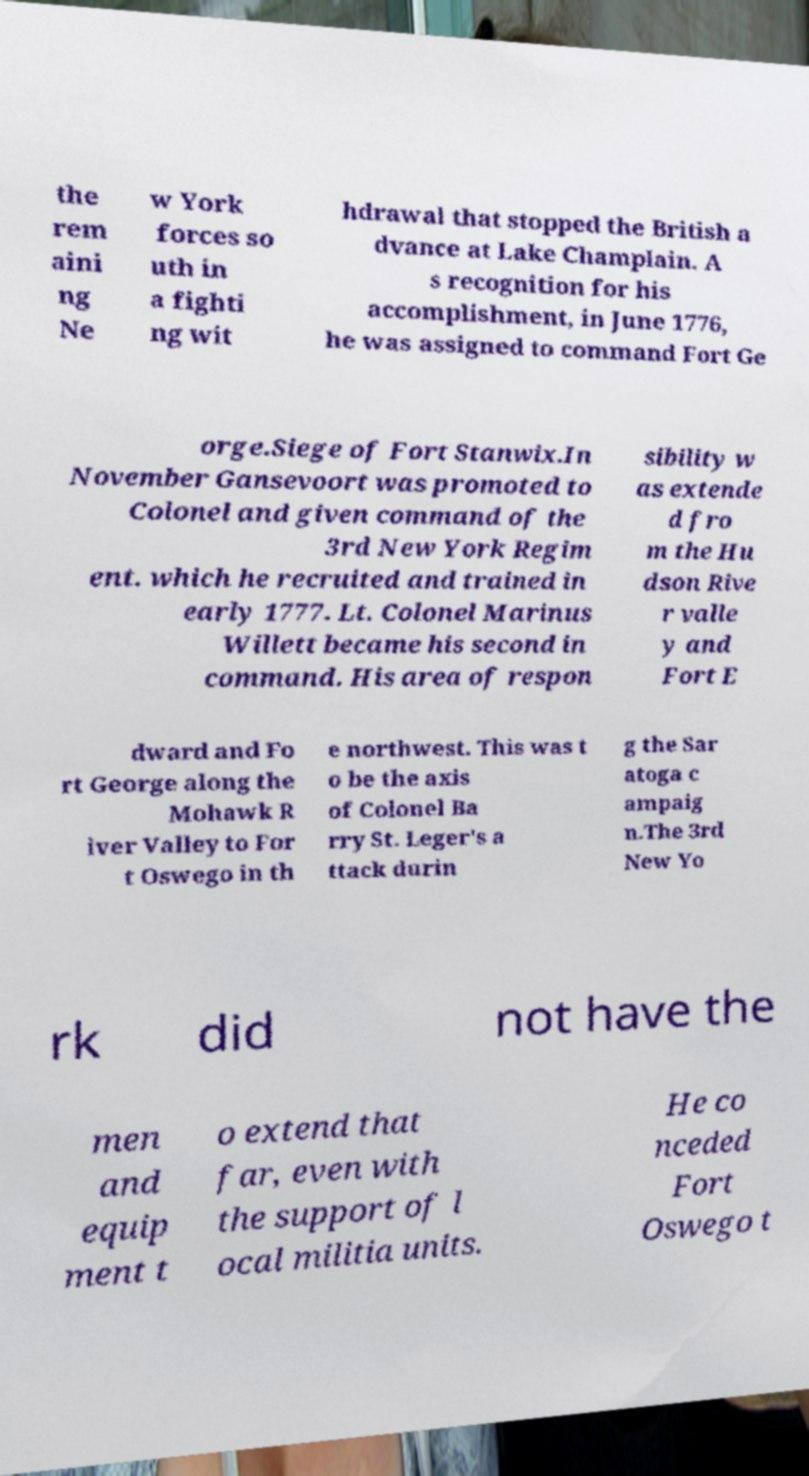Could you extract and type out the text from this image? the rem aini ng Ne w York forces so uth in a fighti ng wit hdrawal that stopped the British a dvance at Lake Champlain. A s recognition for his accomplishment, in June 1776, he was assigned to command Fort Ge orge.Siege of Fort Stanwix.In November Gansevoort was promoted to Colonel and given command of the 3rd New York Regim ent. which he recruited and trained in early 1777. Lt. Colonel Marinus Willett became his second in command. His area of respon sibility w as extende d fro m the Hu dson Rive r valle y and Fort E dward and Fo rt George along the Mohawk R iver Valley to For t Oswego in th e northwest. This was t o be the axis of Colonel Ba rry St. Leger's a ttack durin g the Sar atoga c ampaig n.The 3rd New Yo rk did not have the men and equip ment t o extend that far, even with the support of l ocal militia units. He co nceded Fort Oswego t 